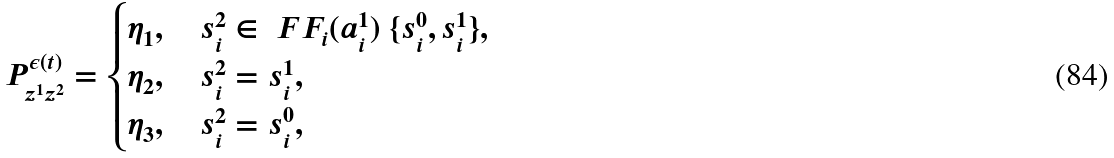Convert formula to latex. <formula><loc_0><loc_0><loc_500><loc_500>P ^ { \epsilon ( t ) } _ { z ^ { 1 } z ^ { 2 } } = \begin{cases} \eta _ { 1 } , \quad s ^ { 2 } _ { i } \in \ F F _ { i } ( a _ { i } ^ { 1 } ) \ \{ s ^ { 0 } _ { i } , s ^ { 1 } _ { i } \} , \\ \eta _ { 2 } , \quad s ^ { 2 } _ { i } = s ^ { 1 } _ { i } , \\ \eta _ { 3 } , \quad s ^ { 2 } _ { i } = s ^ { 0 } _ { i } , \end{cases}</formula> 